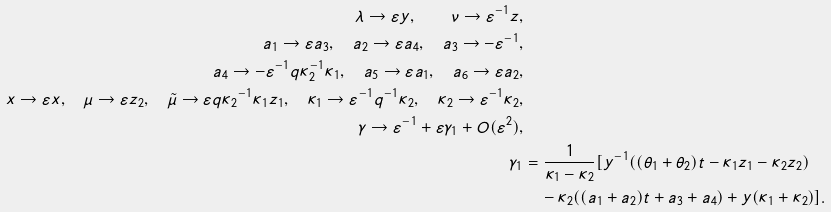<formula> <loc_0><loc_0><loc_500><loc_500>\lambda \to \varepsilon y , \quad \nu \to \varepsilon ^ { - 1 } z , \\ a _ { 1 } \to \varepsilon a _ { 3 } , \quad a _ { 2 } \to \varepsilon a _ { 4 } , \quad a _ { 3 } \to - \varepsilon ^ { - 1 } , \\ a _ { 4 } \to - \varepsilon ^ { - 1 } q \kappa _ { 2 } ^ { - 1 } \kappa _ { 1 } , \quad a _ { 5 } \to \varepsilon a _ { 1 } , \quad a _ { 6 } \to \varepsilon a _ { 2 } , \\ x \to \varepsilon x , \quad \mu \to \varepsilon z _ { 2 } , \quad \tilde { \mu } \to \varepsilon q { \kappa _ { 2 } } ^ { - 1 } \kappa _ { 1 } z _ { 1 } , \quad \kappa _ { 1 } \to \varepsilon ^ { - 1 } q ^ { - 1 } \kappa _ { 2 } , \quad \kappa _ { 2 } \to \varepsilon ^ { - 1 } \kappa _ { 2 } , \\ \gamma \to \varepsilon ^ { - 1 } + \varepsilon \gamma _ { 1 } + O ( \varepsilon ^ { 2 } ) , \\ \gamma _ { 1 } & = \frac { 1 } { \kappa _ { 1 } - \kappa _ { 2 } } [ y ^ { - 1 } ( ( \theta _ { 1 } + \theta _ { 2 } ) t - \kappa _ { 1 } z _ { 1 } - \kappa _ { 2 } z _ { 2 } ) \\ & \quad - \kappa _ { 2 } ( ( a _ { 1 } + a _ { 2 } ) t + a _ { 3 } + a _ { 4 } ) + y ( \kappa _ { 1 } + \kappa _ { 2 } ) ] .</formula> 